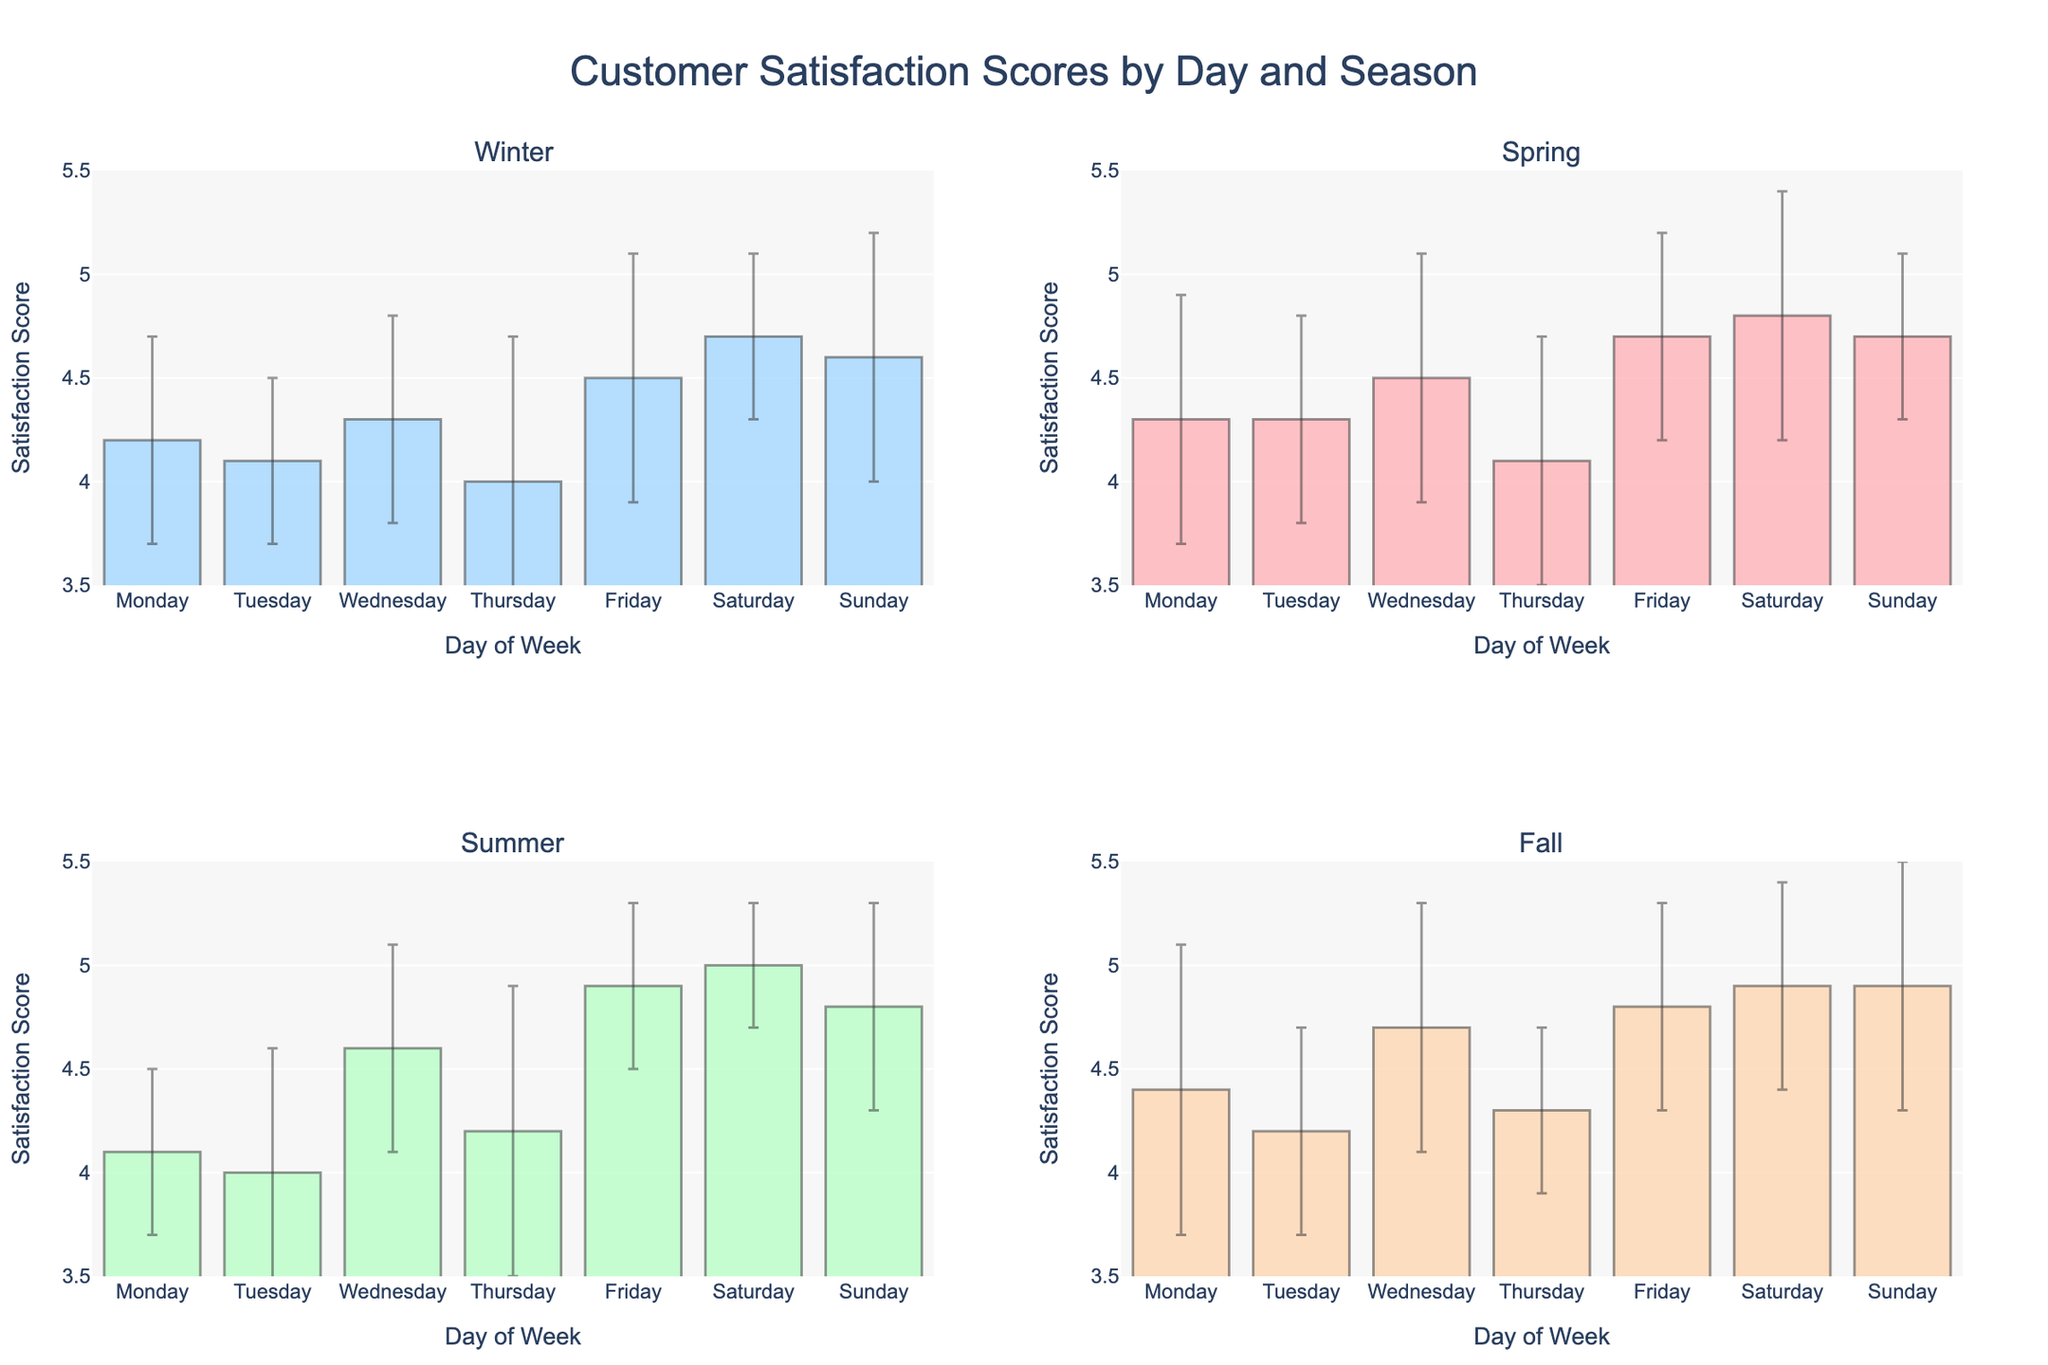What's the title of the figure? The title of the figure is displayed at the top and should accurately summarize the content of the visual. Here, it says "Customer Satisfaction Scores by Day and Season".
Answer: Customer Satisfaction Scores by Day and Season How many subplots are there in the figure? By visually scanning the figure, we can see it is divided into four distinct sections, one for each season.
Answer: 4 Which day of the week has the highest average customer satisfaction score in the Fall? By looking at the bar heights in the Fall subplot, Saturday has the tallest bar, indicating it has the highest average score.
Answer: Saturday What is the range of satisfaction scores on the y-axis? Examining the y-axis labels across all subplots, the satisfaction scores range from 3.5 to 5.5.
Answer: 3.5 to 5.5 Between Winter and Spring, which season shows a higher satisfaction score for Sundays? Comparing the height of the Sunday bars for both Winter and Spring subplots, Spring has a higher bar.
Answer: Spring What is the average customer satisfaction score on Wednesday during Summer? Locate the Summer subplot and find the bar corresponding to Wednesday. The bar height indicates an average score of 4.6.
Answer: 4.6 Which season shows the lowest customer satisfaction score for Thursdays? Comparing the Thursday bars across each subplot, Winter has the lowest bar.
Answer: Winter On average, how does customer satisfaction on Mondays compare between Summer and Fall? By comparing the heights of Monday’s bars in Summer and Fall subplots, Fall is higher than Summer.
Answer: Fall is higher What is the standard deviation for customer satisfaction on Fridays in Winter? Check the error bar lines on the Friday bar in the Winter subplot; the standard deviation is represented as 0.6.
Answer: 0.6 Is the customer satisfaction consistent across the days in Summer? Look at the error bars for each day in the Summer subplot; they show low variation suggesting consistent customer satisfaction across the week.
Answer: Yes, it is consistent 